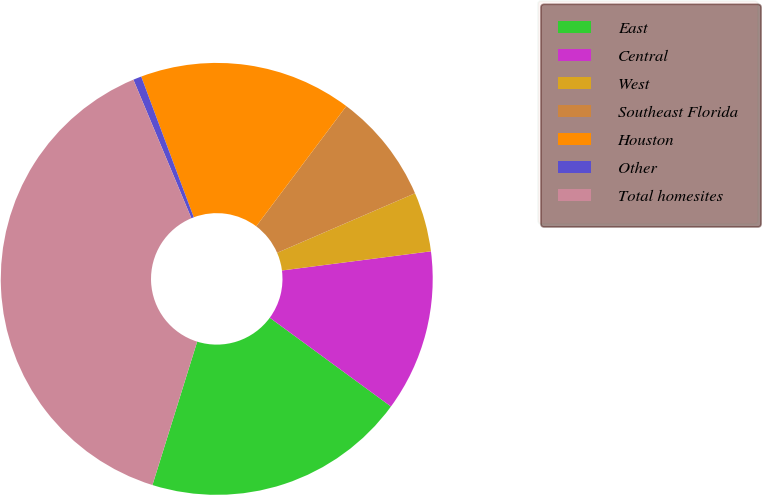Convert chart. <chart><loc_0><loc_0><loc_500><loc_500><pie_chart><fcel>East<fcel>Central<fcel>West<fcel>Southeast Florida<fcel>Houston<fcel>Other<fcel>Total homesites<nl><fcel>19.75%<fcel>12.1%<fcel>4.45%<fcel>8.27%<fcel>15.93%<fcel>0.62%<fcel>38.88%<nl></chart> 